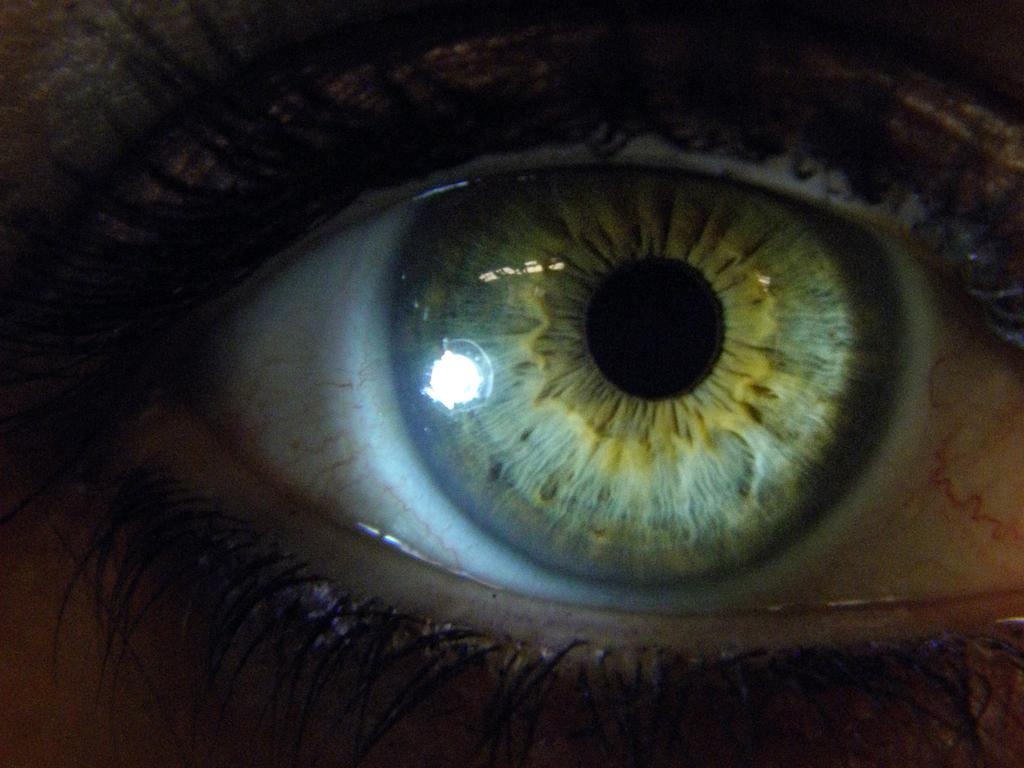What is the main subject of the image? The main subject of the image is an eye. What part of the eye is visible in the image? The eyelids of the person are visible in the image. What color is the kite flying in the image? There is no kite present in the image. Is there any blood visible in the image? There is no blood visible in the image. 